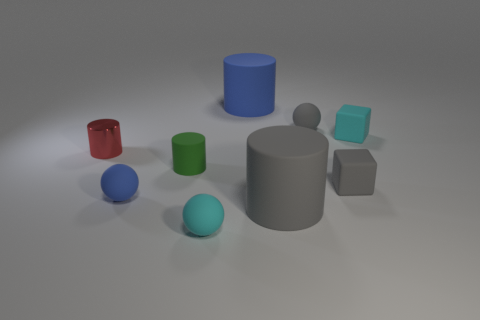How big is the green cylinder?
Make the answer very short. Small. How many small green rubber things are on the left side of the large blue rubber cylinder?
Your answer should be very brief. 1. There is a blue rubber object that is right of the cyan matte object that is to the left of the small gray rubber sphere; what is its size?
Ensure brevity in your answer.  Large. There is a tiny object in front of the small blue rubber thing; is its shape the same as the gray object that is behind the metal object?
Give a very brief answer. Yes. There is a cyan thing that is behind the big cylinder in front of the small red shiny cylinder; what is its shape?
Make the answer very short. Cube. What is the size of the thing that is both on the left side of the small green matte cylinder and on the right side of the red shiny cylinder?
Your answer should be very brief. Small. There is a small green object; is its shape the same as the large object that is in front of the small cyan cube?
Your response must be concise. Yes. There is a red metallic object that is the same shape as the big gray object; what size is it?
Offer a very short reply. Small. There is a small metallic cylinder; is its color the same as the tiny cube in front of the tiny red object?
Your response must be concise. No. What number of other objects are there of the same size as the gray block?
Your response must be concise. 6. 